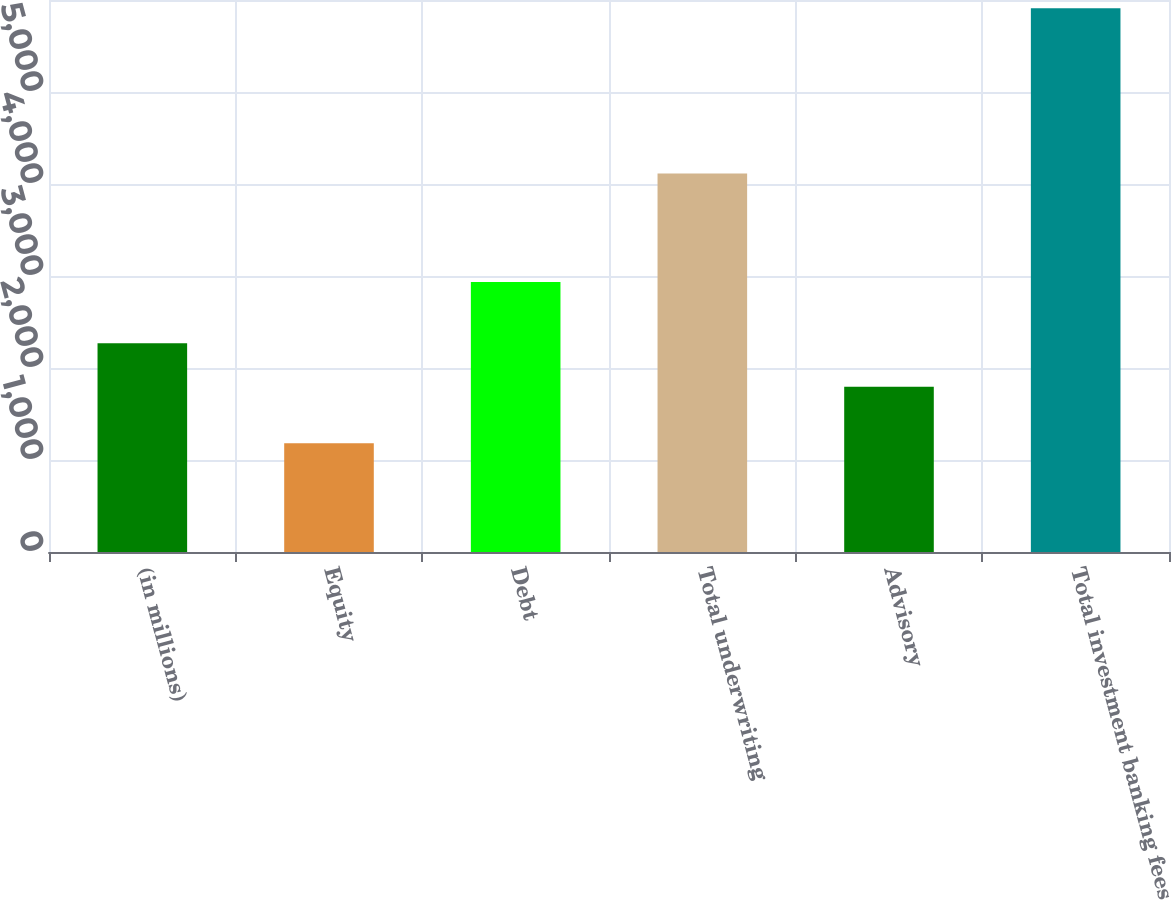Convert chart to OTSL. <chart><loc_0><loc_0><loc_500><loc_500><bar_chart><fcel>(in millions)<fcel>Equity<fcel>Debt<fcel>Total underwriting<fcel>Advisory<fcel>Total investment banking fees<nl><fcel>2269<fcel>1181<fcel>2934<fcel>4115<fcel>1796<fcel>5911<nl></chart> 